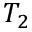Convert formula to latex. <formula><loc_0><loc_0><loc_500><loc_500>T _ { 2 }</formula> 